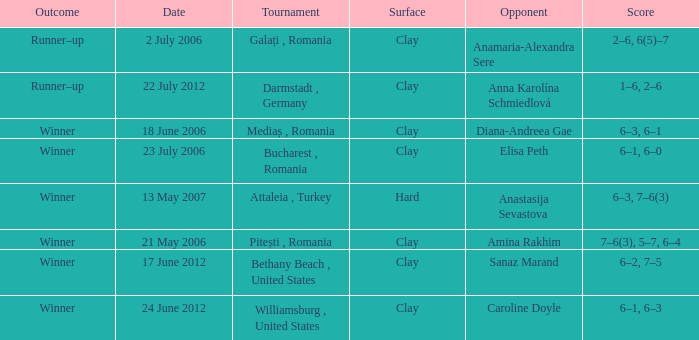What was the score in the match against Sanaz Marand? 6–2, 7–5. 